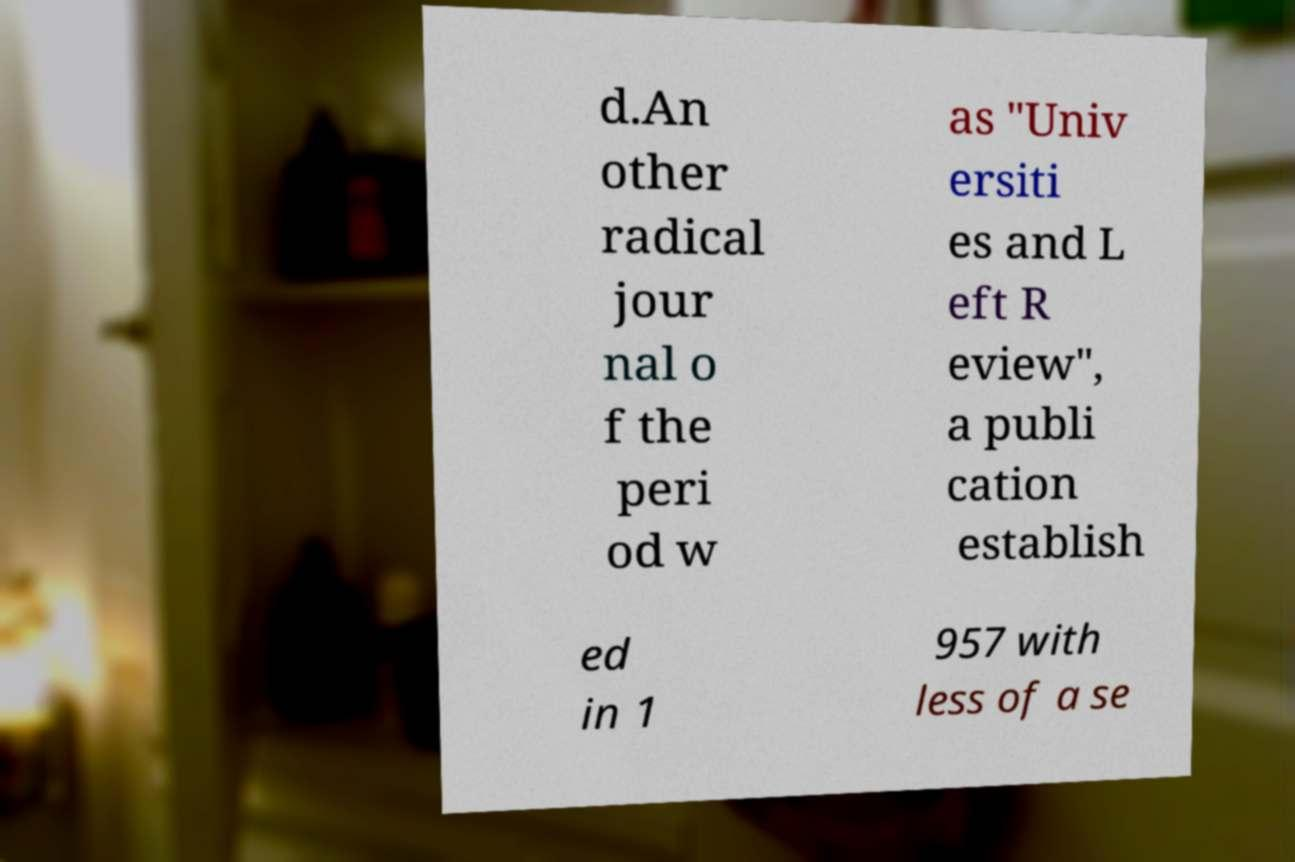There's text embedded in this image that I need extracted. Can you transcribe it verbatim? d.An other radical jour nal o f the peri od w as "Univ ersiti es and L eft R eview", a publi cation establish ed in 1 957 with less of a se 